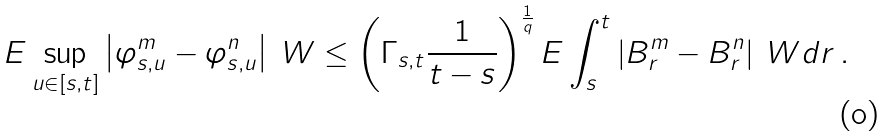<formula> <loc_0><loc_0><loc_500><loc_500>E \sup _ { u \in [ s , t ] } \left | \varphi _ { s , u } ^ { m } - \varphi _ { s , u } ^ { n } \right | \ W \leq \left ( \Gamma _ { s , t } \frac { 1 } { t - s } \right ) ^ { \frac { 1 } { q } } E \int _ { s } ^ { t } \left | B _ { r } ^ { m } - B _ { r } ^ { n } \right | \ W d r \, .</formula> 